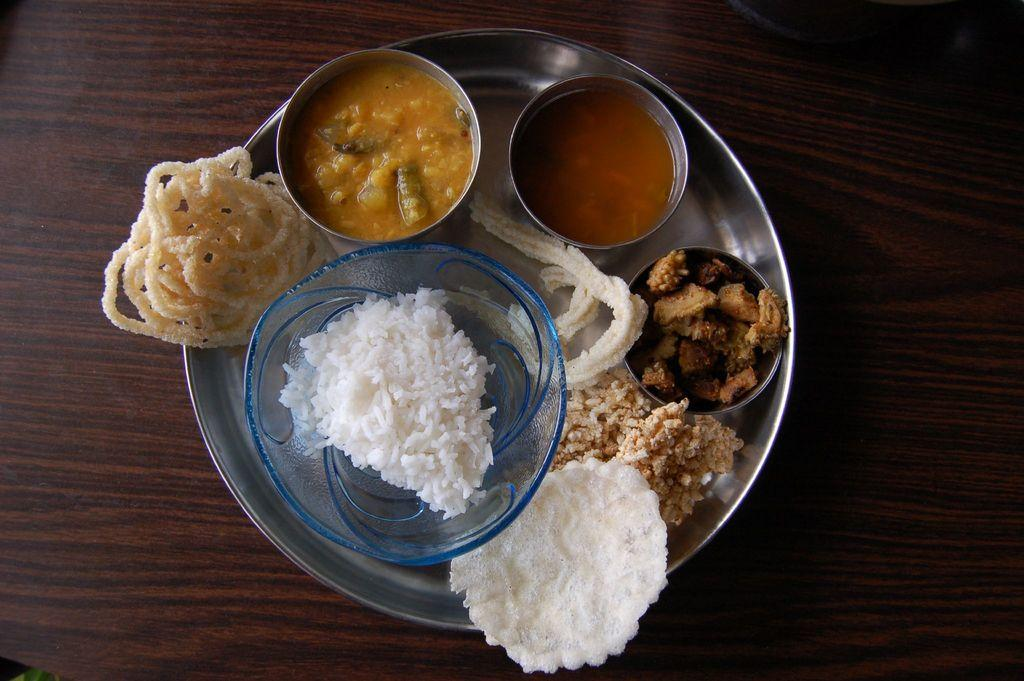What is present on the surface in the image? There is a plate and bowls in the image. What can be found inside the bowls? There is food in the image. What type of surface is the plate and bowls resting on? The wooden platform is present in the image. What representative: Who is the representative of the nation in the image? There is not present in the image, as there is no person or indication of a nation in the provided facts. 